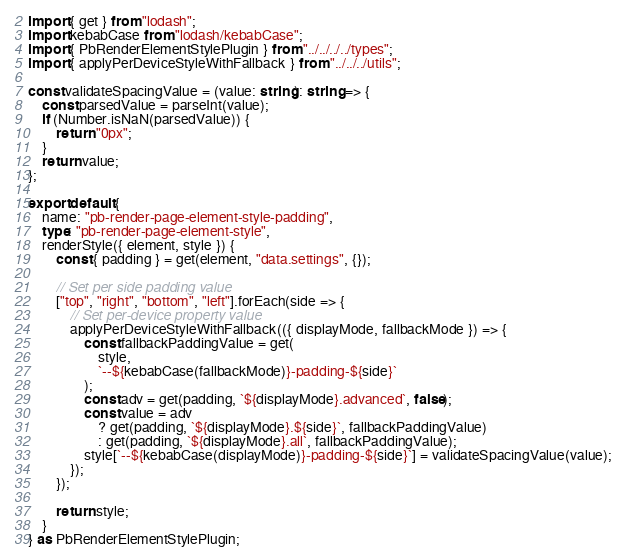<code> <loc_0><loc_0><loc_500><loc_500><_TypeScript_>import { get } from "lodash";
import kebabCase from "lodash/kebabCase";
import { PbRenderElementStylePlugin } from "../../../../types";
import { applyPerDeviceStyleWithFallback } from "../../../utils";

const validateSpacingValue = (value: string): string => {
    const parsedValue = parseInt(value);
    if (Number.isNaN(parsedValue)) {
        return "0px";
    }
    return value;
};

export default {
    name: "pb-render-page-element-style-padding",
    type: "pb-render-page-element-style",
    renderStyle({ element, style }) {
        const { padding } = get(element, "data.settings", {});

        // Set per side padding value
        ["top", "right", "bottom", "left"].forEach(side => {
            // Set per-device property value
            applyPerDeviceStyleWithFallback(({ displayMode, fallbackMode }) => {
                const fallbackPaddingValue = get(
                    style,
                    `--${kebabCase(fallbackMode)}-padding-${side}`
                );
                const adv = get(padding, `${displayMode}.advanced`, false);
                const value = adv
                    ? get(padding, `${displayMode}.${side}`, fallbackPaddingValue)
                    : get(padding, `${displayMode}.all`, fallbackPaddingValue);
                style[`--${kebabCase(displayMode)}-padding-${side}`] = validateSpacingValue(value);
            });
        });

        return style;
    }
} as PbRenderElementStylePlugin;
</code> 